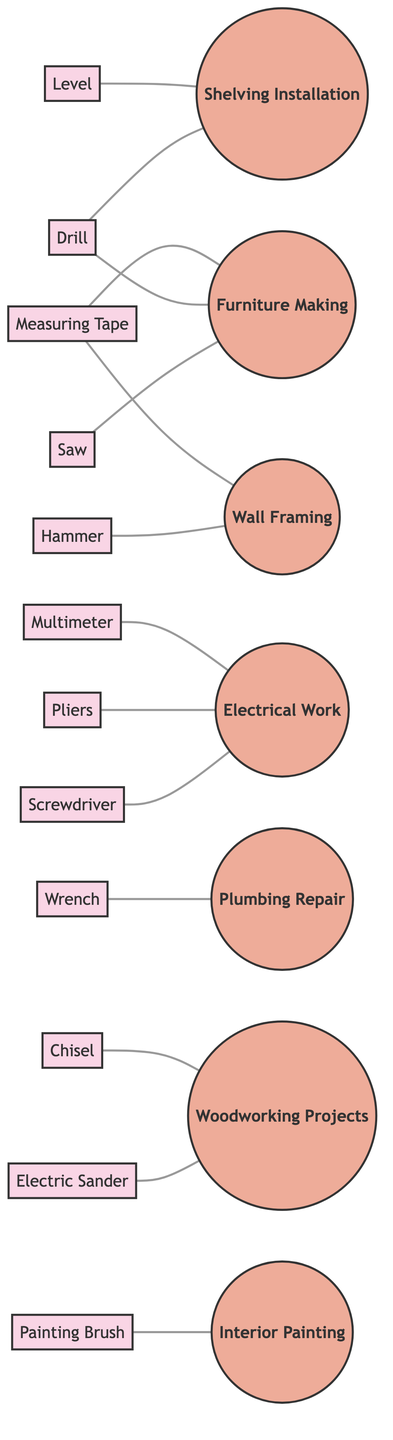What's the total number of tools represented in the diagram? The diagram lists 12 unique tools in the nodes section. To find the total, I count each tool node: Saw, Drill, Level, Hammer, Screwdriver, Wrench, Measuring Tape, Pliers, Electric Sander, Multimeter, Painting Brush, and Chisel, which totals 12.
Answer: 12 Which task is associated with the Drill? There are two connections from the Drill node. The edges indicate that the Drill is associated with both Shelving Installation and Furniture Making tasks. Thus, I can confirm that the Drill is linked with these two tasks.
Answer: Shelving Installation, Furniture Making How many tasks are linked to the Hammer tool? By checking the connections from the Hammer node, I find that it is linked to only one task, which is Wall Framing. Thus, I don't need to look for additional connections, as there is only one.
Answer: 1 What is the relationship between the Multimeter and Electrical Work? The diagram shows a direct edge from the Multimeter to the Electrical Work task. This indicates that the Multimeter is used for Electrical Work, establishing the direct relationship between these two nodes.
Answer: Electrical Work Which tool is used for Woodworking Projects? There are two connections leading to the Woodworking Projects task. The edges indicate that both the Electric Sander and Chisel are linked to Woodworking Projects, confirming that these two tools are used for such tasks.
Answer: Electric Sander, Chisel How many tools are associated with the Furniture Making task? Looking at the edges connected to the Furniture Making task, I see three tools linked: Saw, Drill, and Measuring Tape. By counting these connections, I can determine that there are three tools associated with Furniture Making.
Answer: 3 Which task requires the use of a Wrench? The edge from the Wrench node shows that it is solely connected to the Plumbing Repair task. This indicates that the Wrench is specifically required for this task with no alternative connections.
Answer: Plumbing Repair Which tool is necessary for Interior Painting? Checking the node connections, the Painting Brush has a direct edge connecting it to the Interior Painting task. This means that the Painting Brush is specifically required for this task.
Answer: Painting Brush 